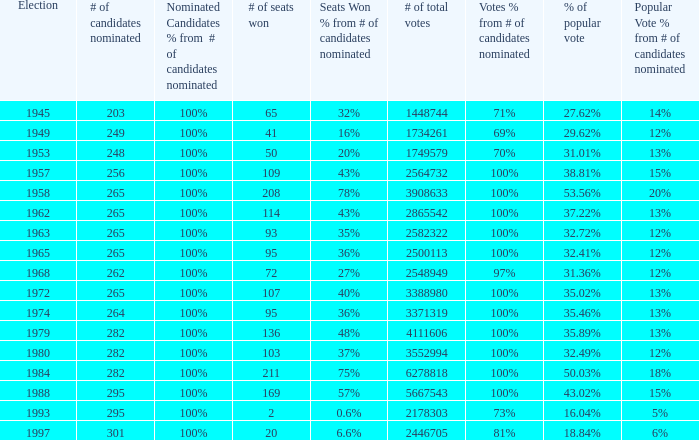What is the election year when the # of candidates nominated was 262? 1.0. 